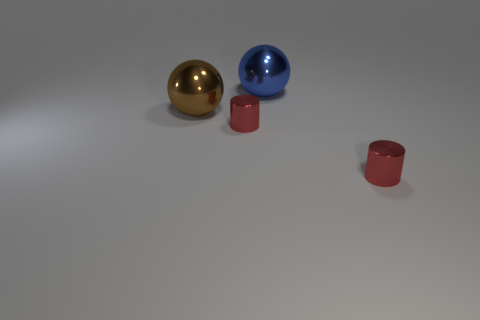Add 3 blue objects. How many objects exist? 7 Subtract all blue balls. Subtract all blue balls. How many objects are left? 2 Add 2 small cylinders. How many small cylinders are left? 4 Add 2 tiny red things. How many tiny red things exist? 4 Subtract 0 brown cylinders. How many objects are left? 4 